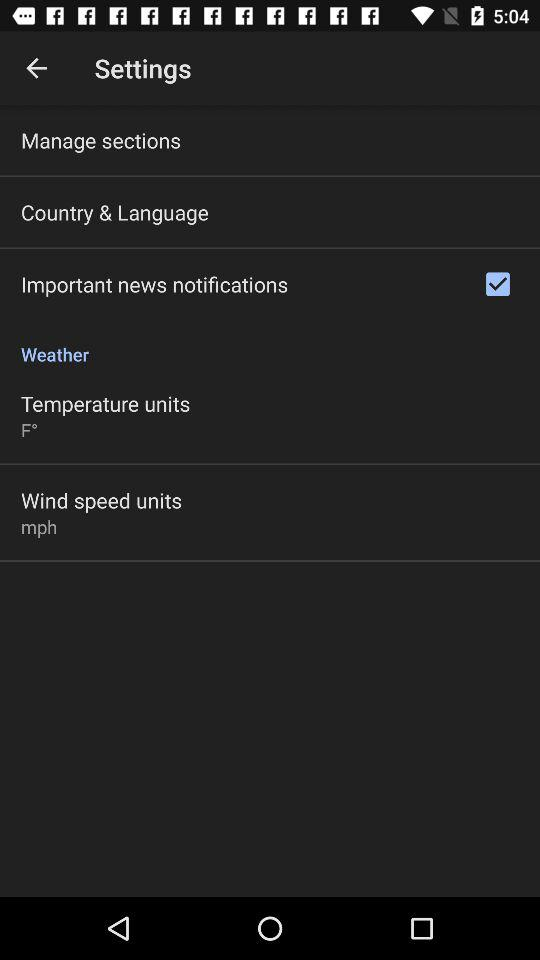What is the selected unit of wind speed? The selected unit of wind speed is mph. 